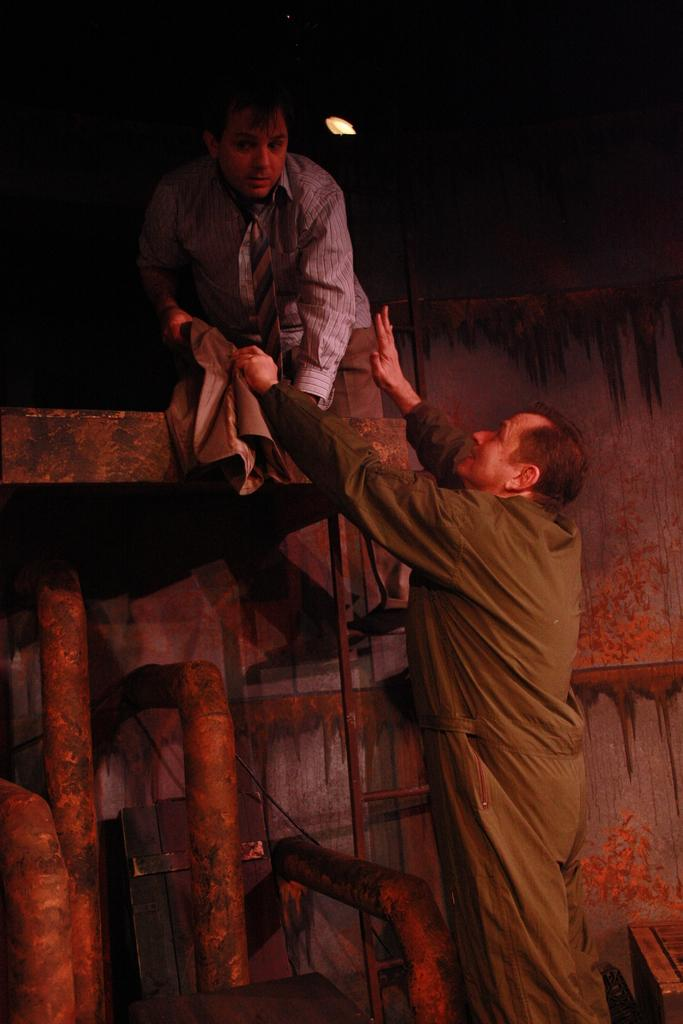What is the position of the man in the image? The man is standing on the right side of the image. What is near the man in the image? There is a stand near the man. What object is present in the image that is used for climbing? There is a ladder in the image, and another person is on the ladder. What can be seen in the background of the image? There is a wall in the background of the image. What type of coach can be seen in the image? There is no coach present in the image. What color is the sheet draped over the ladder in the image? There is no sheet present in the image; the ladder is visible without any covering. 